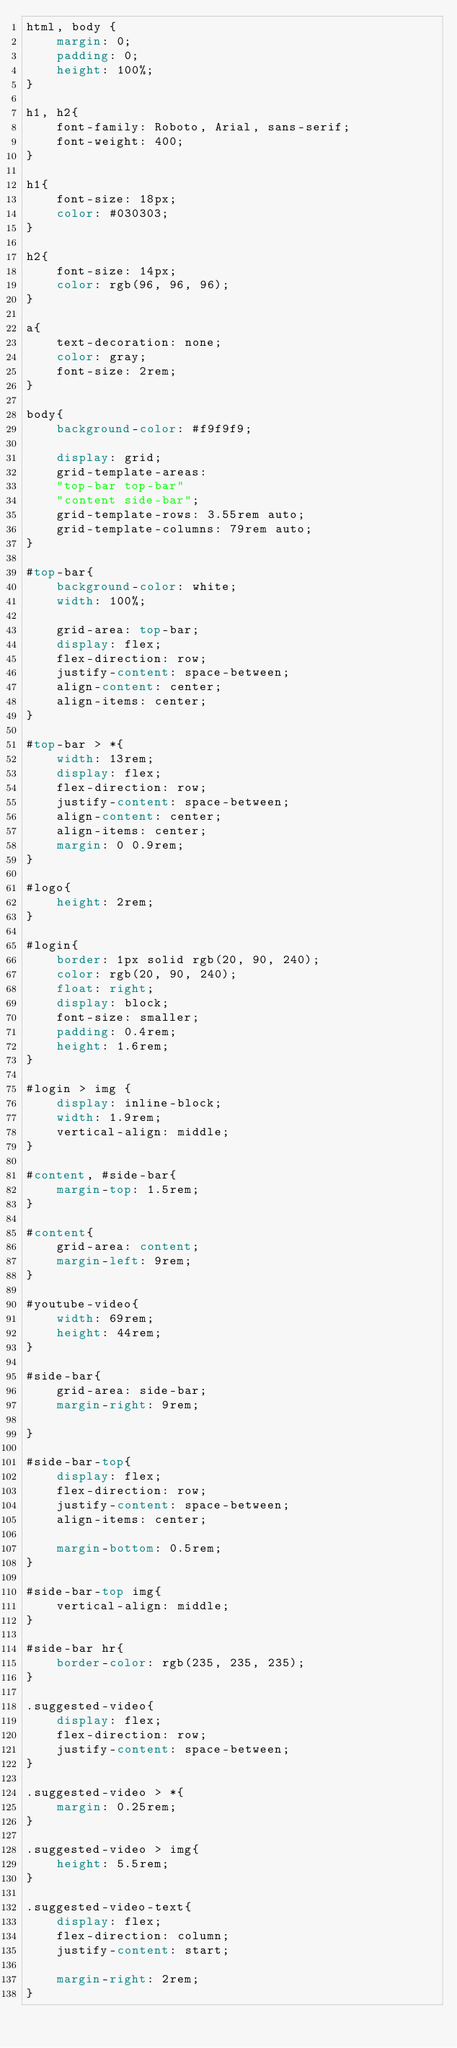Convert code to text. <code><loc_0><loc_0><loc_500><loc_500><_CSS_>html, body {
    margin: 0;
    padding: 0;
    height: 100%;
}

h1, h2{
    font-family: Roboto, Arial, sans-serif;
    font-weight: 400;
}

h1{
    font-size: 18px;
    color: #030303;
}

h2{
    font-size: 14px;
    color: rgb(96, 96, 96);
}

a{
    text-decoration: none;
    color: gray;
    font-size: 2rem;
}

body{
    background-color: #f9f9f9;

    display: grid;
    grid-template-areas:
    "top-bar top-bar"
    "content side-bar";
    grid-template-rows: 3.55rem auto;
    grid-template-columns: 79rem auto;
}

#top-bar{
    background-color: white;
    width: 100%;

    grid-area: top-bar;
    display: flex;
    flex-direction: row;
    justify-content: space-between;
    align-content: center;
    align-items: center;
}

#top-bar > *{
    width: 13rem;
    display: flex;
    flex-direction: row;
    justify-content: space-between;
    align-content: center;
    align-items: center;
    margin: 0 0.9rem;
}

#logo{
    height: 2rem;
}

#login{
    border: 1px solid rgb(20, 90, 240);
    color: rgb(20, 90, 240);
    float: right;
    display: block;
    font-size: smaller;
    padding: 0.4rem;
    height: 1.6rem;
}

#login > img {
    display: inline-block;
    width: 1.9rem;
    vertical-align: middle;
}

#content, #side-bar{
    margin-top: 1.5rem;
}

#content{
    grid-area: content;
    margin-left: 9rem;
}

#youtube-video{
    width: 69rem;
    height: 44rem;
}

#side-bar{
    grid-area: side-bar;
    margin-right: 9rem;

}

#side-bar-top{
    display: flex;
    flex-direction: row;
    justify-content: space-between;
    align-items: center;

    margin-bottom: 0.5rem;
}

#side-bar-top img{
    vertical-align: middle;
}

#side-bar hr{
    border-color: rgb(235, 235, 235);
}

.suggested-video{
    display: flex;
    flex-direction: row;
    justify-content: space-between;
}

.suggested-video > *{
    margin: 0.25rem;
}

.suggested-video > img{
    height: 5.5rem;
}

.suggested-video-text{
    display: flex;
    flex-direction: column;
    justify-content: start;

    margin-right: 2rem;
}</code> 